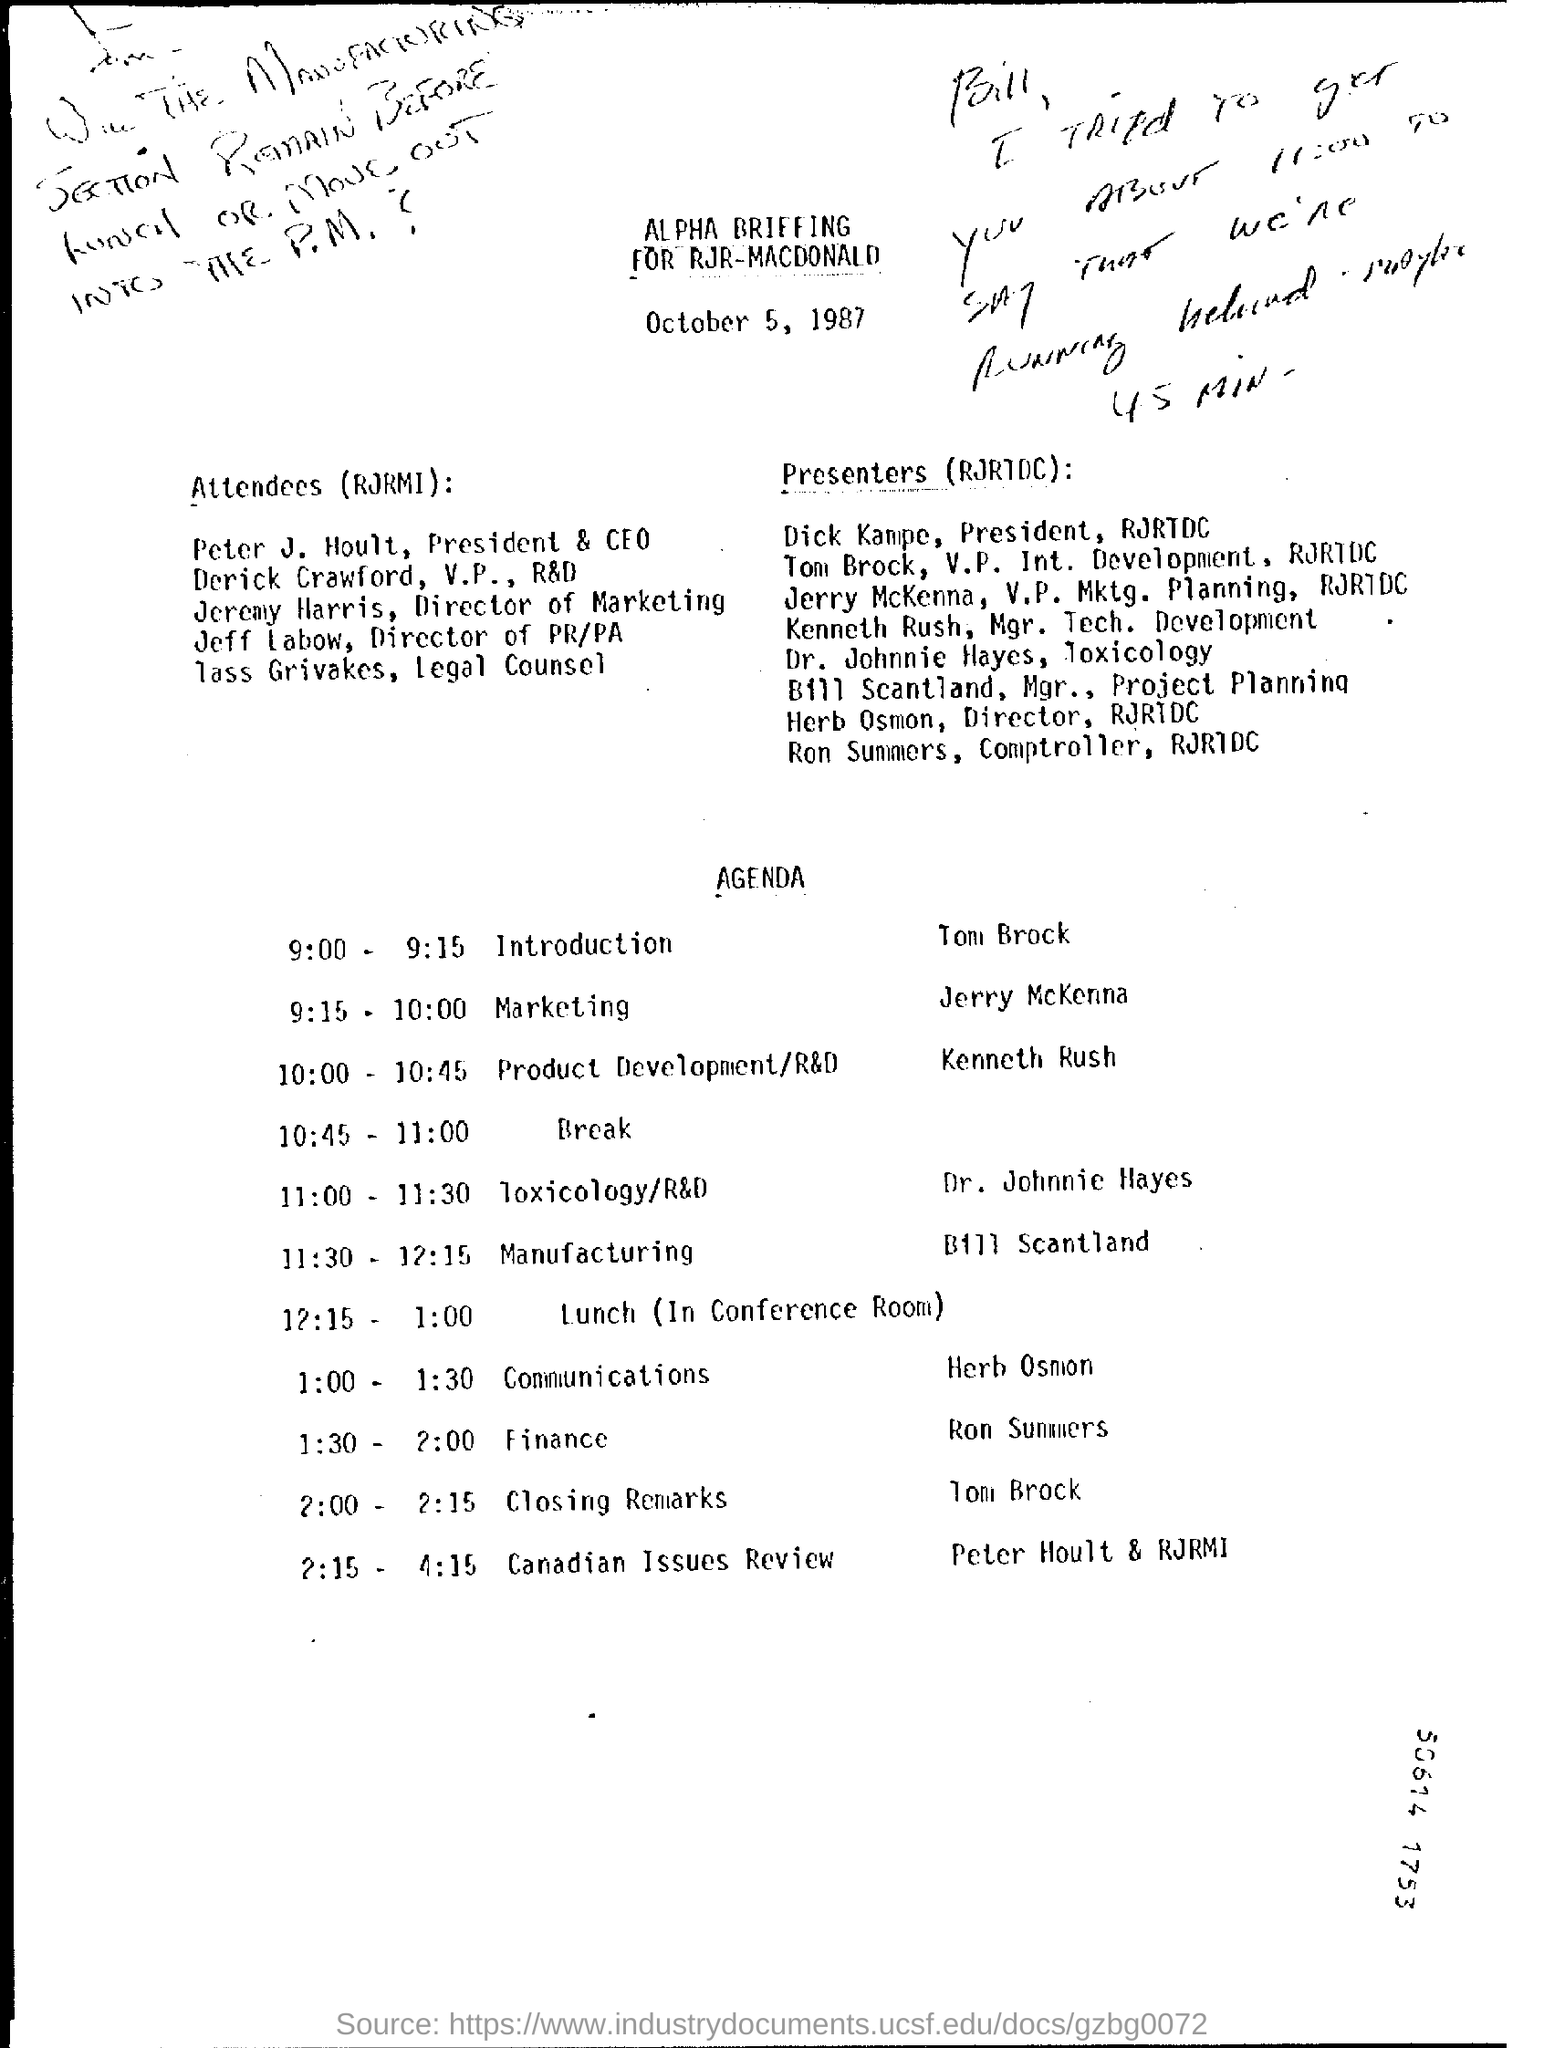Point out several critical features in this image. Tom Brock gives the introduction. The title of the given document is 'ALPHA BRIEFING FOR RJR-MACDONALD..' 